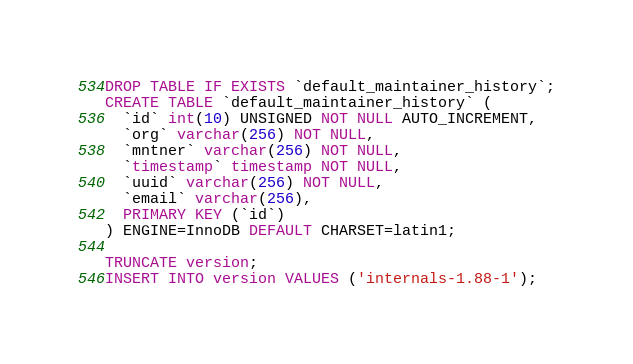<code> <loc_0><loc_0><loc_500><loc_500><_SQL_>DROP TABLE IF EXISTS `default_maintainer_history`;
CREATE TABLE `default_maintainer_history` (
  `id` int(10) UNSIGNED NOT NULL AUTO_INCREMENT,
  `org` varchar(256) NOT NULL,
  `mntner` varchar(256) NOT NULL,
  `timestamp` timestamp NOT NULL,
  `uuid` varchar(256) NOT NULL,
  `email` varchar(256),
  PRIMARY KEY (`id`)
) ENGINE=InnoDB DEFAULT CHARSET=latin1;

TRUNCATE version;
INSERT INTO version VALUES ('internals-1.88-1');
</code> 